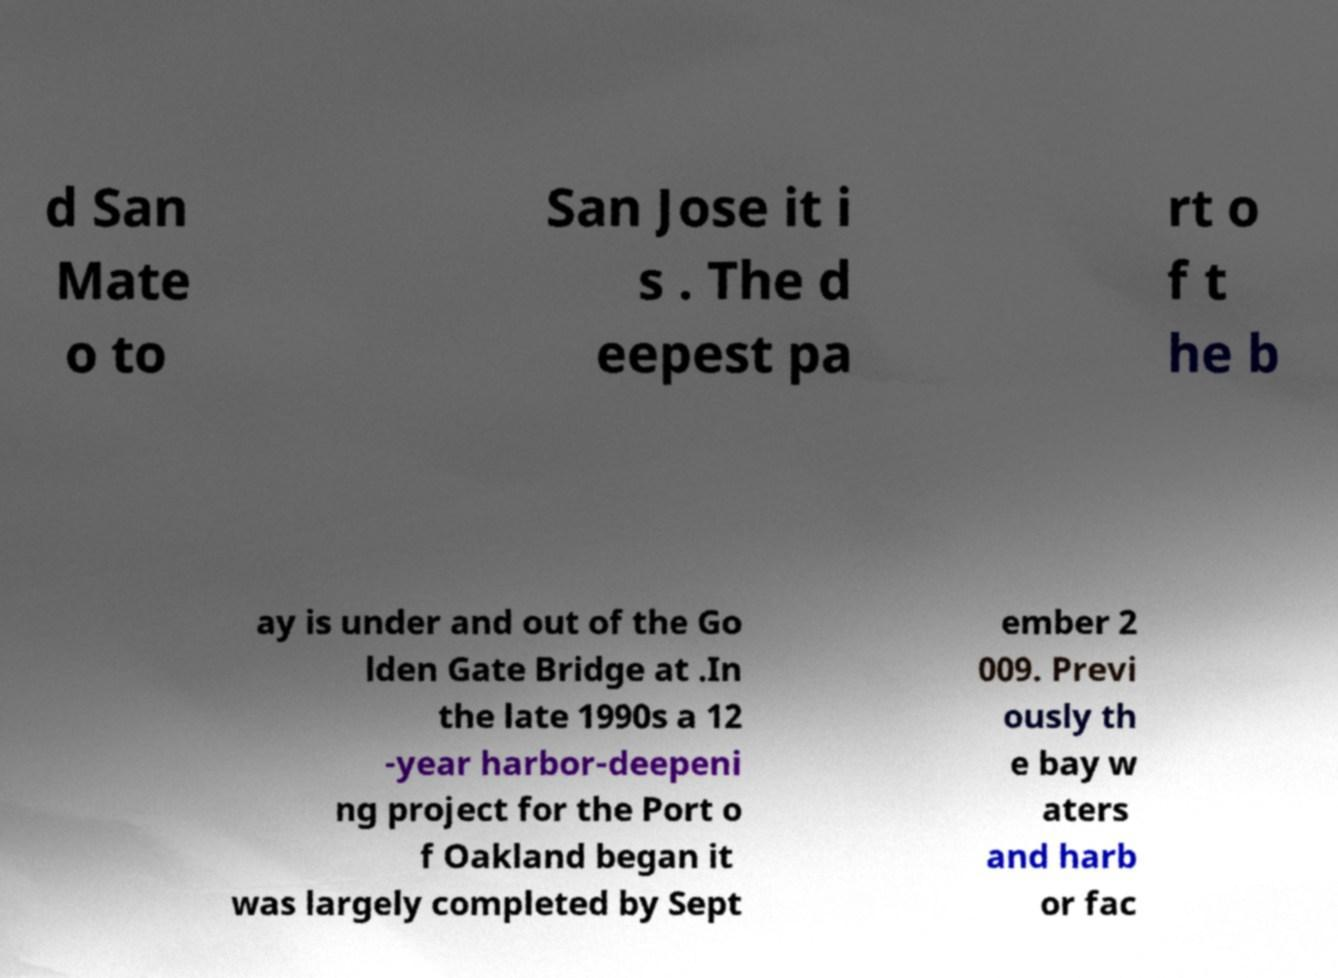I need the written content from this picture converted into text. Can you do that? d San Mate o to San Jose it i s . The d eepest pa rt o f t he b ay is under and out of the Go lden Gate Bridge at .In the late 1990s a 12 -year harbor-deepeni ng project for the Port o f Oakland began it was largely completed by Sept ember 2 009. Previ ously th e bay w aters and harb or fac 